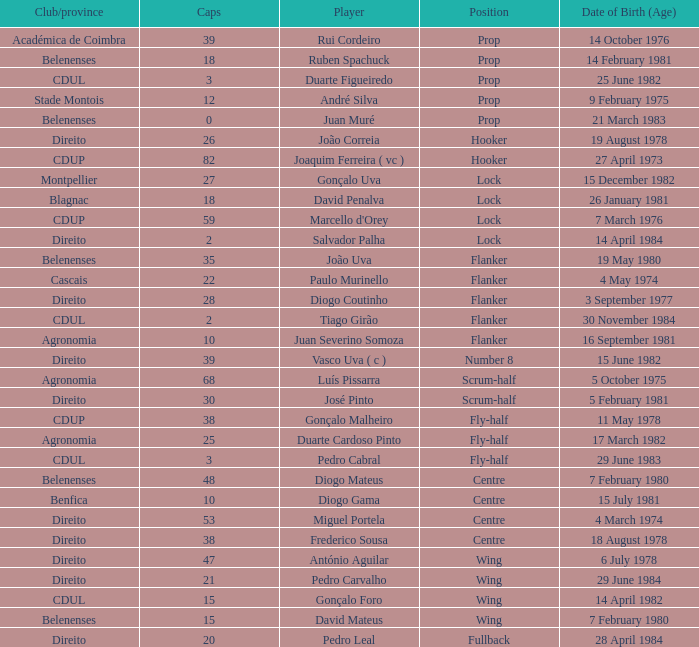How many caps have a Date of Birth (Age) of 15 july 1981? 1.0. 